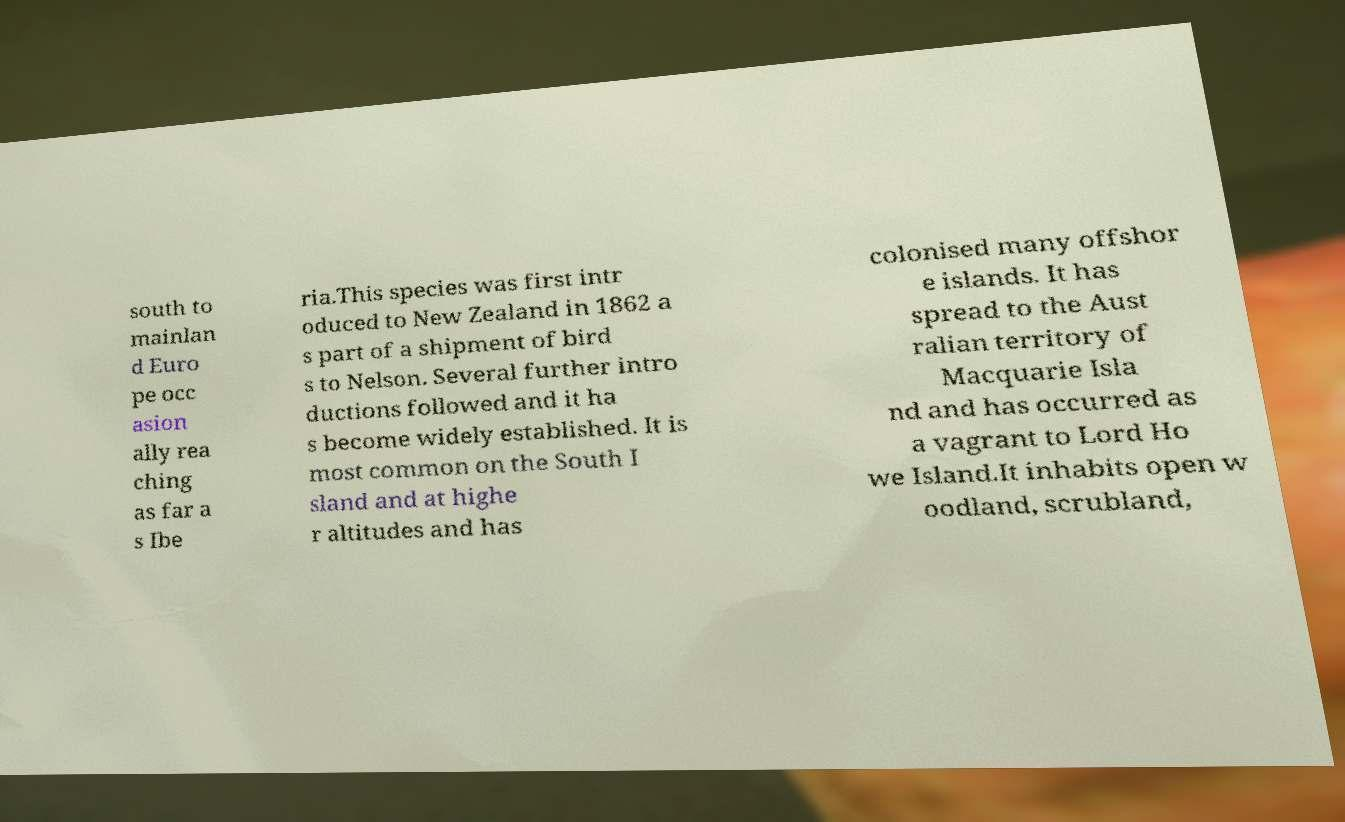Please read and relay the text visible in this image. What does it say? south to mainlan d Euro pe occ asion ally rea ching as far a s Ibe ria.This species was first intr oduced to New Zealand in 1862 a s part of a shipment of bird s to Nelson. Several further intro ductions followed and it ha s become widely established. It is most common on the South I sland and at highe r altitudes and has colonised many offshor e islands. It has spread to the Aust ralian territory of Macquarie Isla nd and has occurred as a vagrant to Lord Ho we Island.It inhabits open w oodland, scrubland, 